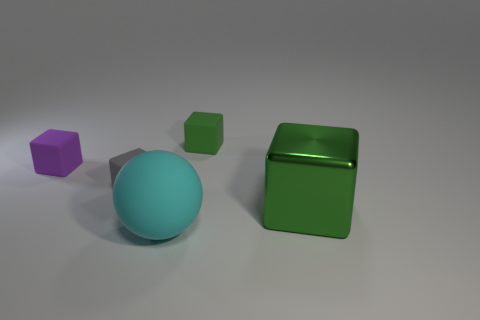Subtract all rubber cubes. How many cubes are left? 1 Subtract all purple spheres. How many green cubes are left? 2 Subtract all green blocks. How many blocks are left? 2 Add 5 brown blocks. How many objects exist? 10 Subtract 0 cyan cubes. How many objects are left? 5 Subtract all cubes. How many objects are left? 1 Subtract 1 balls. How many balls are left? 0 Subtract all red blocks. Subtract all cyan cylinders. How many blocks are left? 4 Subtract all blue blocks. Subtract all small green matte objects. How many objects are left? 4 Add 5 things. How many things are left? 10 